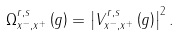<formula> <loc_0><loc_0><loc_500><loc_500>\Omega _ { x ^ { - } , x ^ { + } } ^ { r , s } \left ( g \right ) = \left | V _ { x ^ { - } , x ^ { + } } ^ { r , s } \left ( g \right ) \right | ^ { 2 } .</formula> 